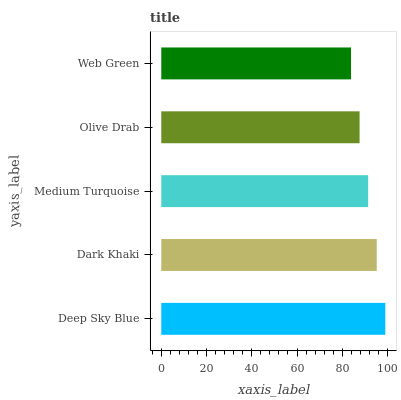Is Web Green the minimum?
Answer yes or no. Yes. Is Deep Sky Blue the maximum?
Answer yes or no. Yes. Is Dark Khaki the minimum?
Answer yes or no. No. Is Dark Khaki the maximum?
Answer yes or no. No. Is Deep Sky Blue greater than Dark Khaki?
Answer yes or no. Yes. Is Dark Khaki less than Deep Sky Blue?
Answer yes or no. Yes. Is Dark Khaki greater than Deep Sky Blue?
Answer yes or no. No. Is Deep Sky Blue less than Dark Khaki?
Answer yes or no. No. Is Medium Turquoise the high median?
Answer yes or no. Yes. Is Medium Turquoise the low median?
Answer yes or no. Yes. Is Deep Sky Blue the high median?
Answer yes or no. No. Is Dark Khaki the low median?
Answer yes or no. No. 